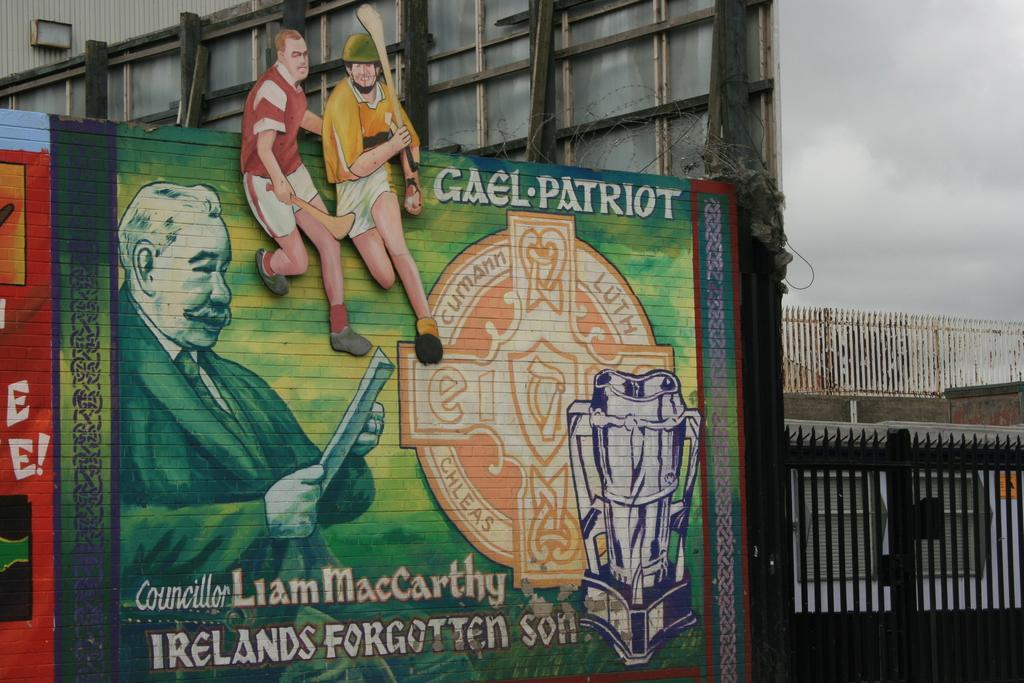<image>
Share a concise interpretation of the image provided. a green sign outside with Irelands on it 